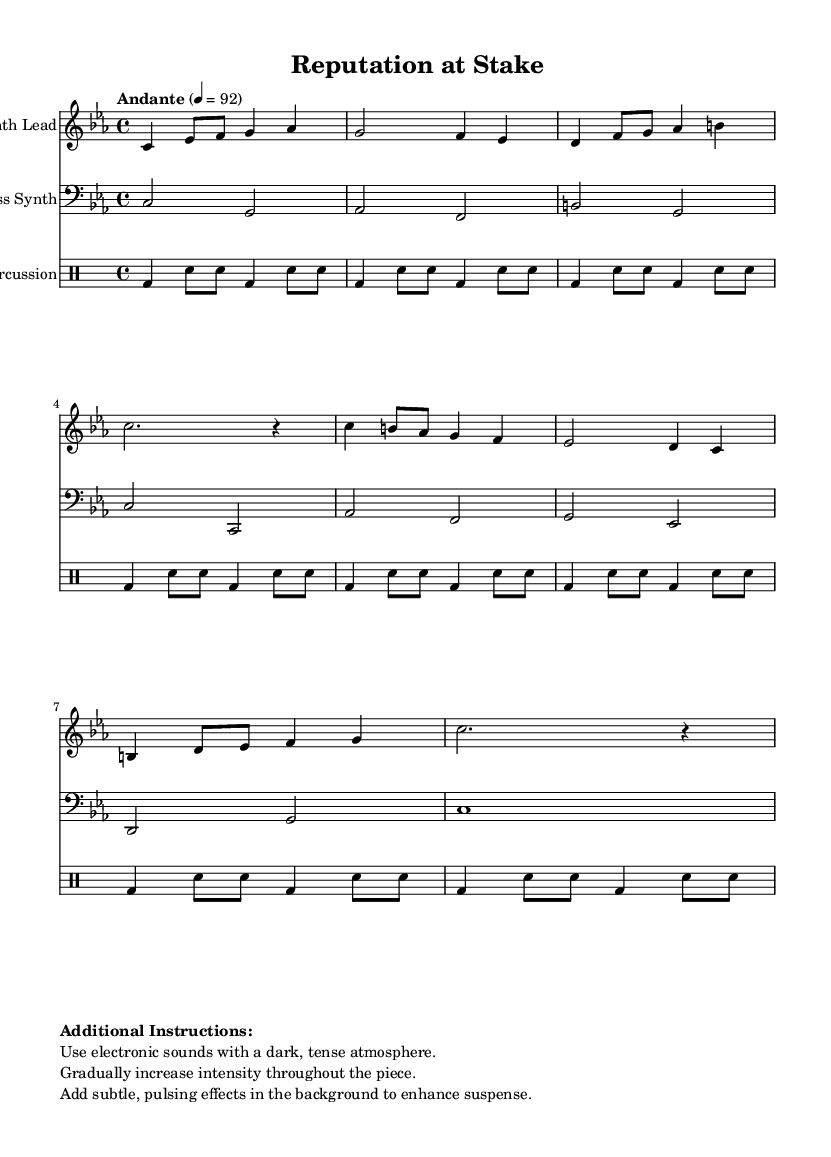What is the key signature of this music? The key signature indicated at the beginning of the score is C minor, which has three flats (B flat, E flat, and A flat).
Answer: C minor What is the time signature of this piece? The time signature is stated in the score as 4/4, which means there are four beats in each measure and the quarter note gets one beat.
Answer: 4/4 What is the tempo marking in this music? The tempo marking provided in the score is "Andante" with a metronome marking of 92, suggesting a moderately slow pace.
Answer: Andante 92 How many measures are there in the Synth Lead part? By counting the total number of measures in the Synth Lead staff, there are 8 measures in total.
Answer: 8 Which instrument plays the bass part? The staff labeled "Bass Synth" indicates that this part is played on a synthesizer instrument with a bass register.
Answer: Bass Synth What kind of atmosphere is recommended for this composition? The additional instructions specify using electronic sounds with a dark, tense atmosphere to enhance the overall mood of the piece.
Answer: Dark, tense atmosphere What is the primary rhythmic element used in the percussion? The percussion part primarily utilizes bass drum patterns with snare hits, contributing to the tension and suspense of the music.
Answer: Bass drum and snare 